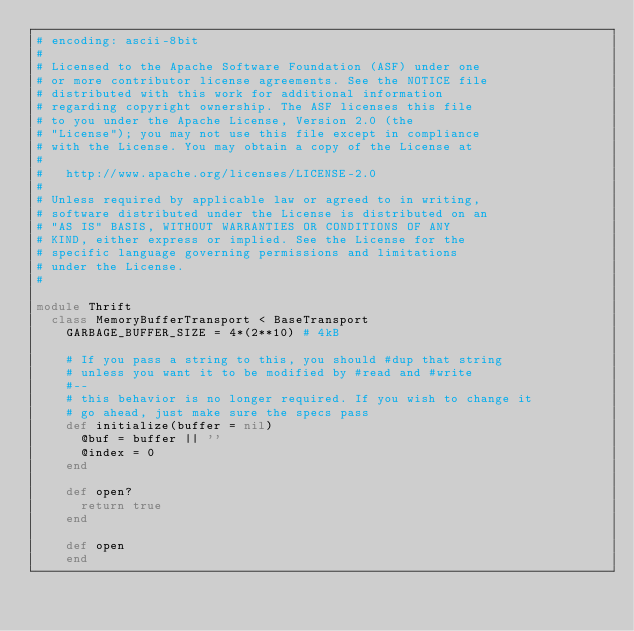Convert code to text. <code><loc_0><loc_0><loc_500><loc_500><_Ruby_># encoding: ascii-8bit
# 
# Licensed to the Apache Software Foundation (ASF) under one
# or more contributor license agreements. See the NOTICE file
# distributed with this work for additional information
# regarding copyright ownership. The ASF licenses this file
# to you under the Apache License, Version 2.0 (the
# "License"); you may not use this file except in compliance
# with the License. You may obtain a copy of the License at
# 
#   http://www.apache.org/licenses/LICENSE-2.0
# 
# Unless required by applicable law or agreed to in writing,
# software distributed under the License is distributed on an
# "AS IS" BASIS, WITHOUT WARRANTIES OR CONDITIONS OF ANY
# KIND, either express or implied. See the License for the
# specific language governing permissions and limitations
# under the License.
#

module Thrift
  class MemoryBufferTransport < BaseTransport
    GARBAGE_BUFFER_SIZE = 4*(2**10) # 4kB

    # If you pass a string to this, you should #dup that string
    # unless you want it to be modified by #read and #write
    #--
    # this behavior is no longer required. If you wish to change it
    # go ahead, just make sure the specs pass
    def initialize(buffer = nil)
      @buf = buffer || ''
      @index = 0
    end

    def open?
      return true
    end

    def open
    end
</code> 